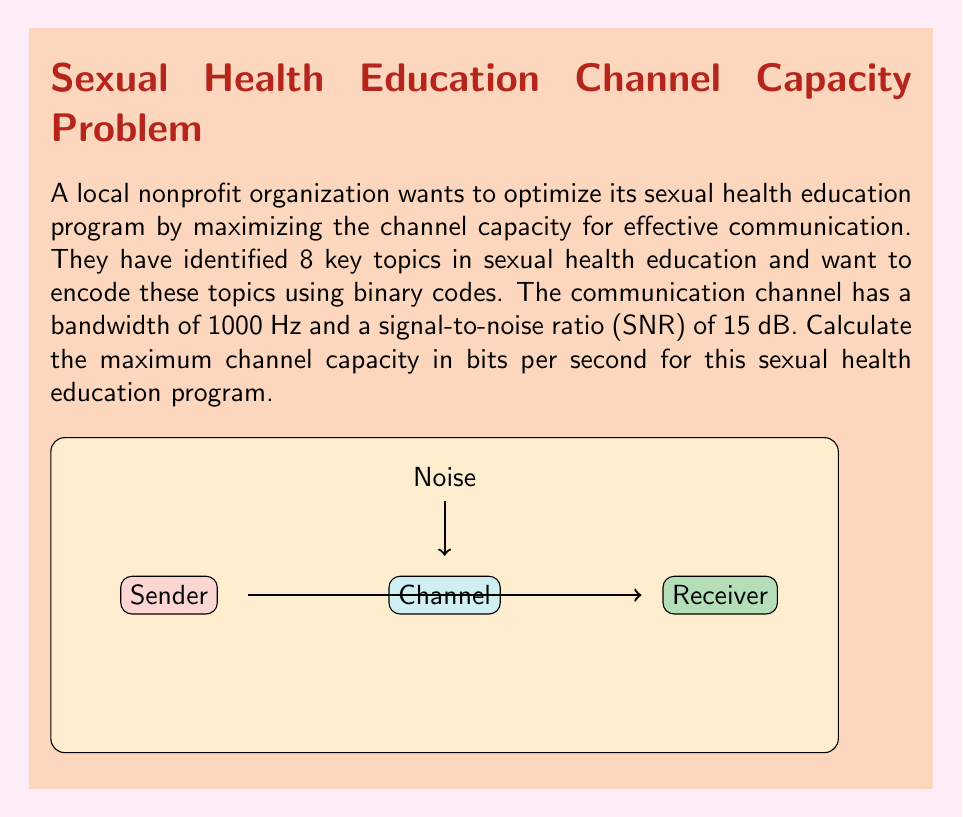Solve this math problem. To solve this problem, we'll use the Shannon-Hartley theorem, which gives the channel capacity for a noisy channel. The steps are as follows:

1) The Shannon-Hartley theorem states that the channel capacity $C$ is:

   $$C = B \log_2(1 + SNR)$$

   where $B$ is the bandwidth in Hz and SNR is the signal-to-noise ratio.

2) We're given the bandwidth $B = 1000$ Hz.

3) The SNR is given as 15 dB. We need to convert this to a linear scale:
   
   $$SNR_{linear} = 10^{SNR_{dB}/10} = 10^{15/10} = 10^{1.5} \approx 31.6228$$

4) Now we can plug these values into the Shannon-Hartley formula:

   $$C = 1000 \log_2(1 + 31.6228)$$

5) Calculate:
   
   $$C = 1000 \log_2(32.6228) \approx 1000 * 5.0279 \approx 5027.9$$

6) Therefore, the channel capacity is approximately 5027.9 bits per second.

This means the nonprofit can transmit up to 5027.9 bits of information about sexual health topics per second through this channel, allowing for effective and efficient communication of their educational content.
Answer: 5027.9 bits/second 